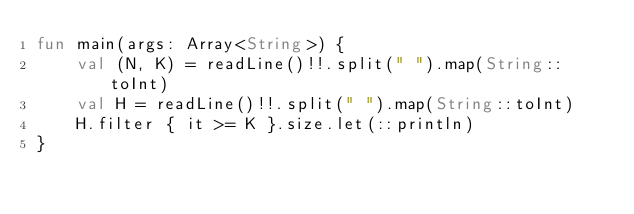Convert code to text. <code><loc_0><loc_0><loc_500><loc_500><_Kotlin_>fun main(args: Array<String>) {
    val (N, K) = readLine()!!.split(" ").map(String::toInt)
    val H = readLine()!!.split(" ").map(String::toInt)
    H.filter { it >= K }.size.let(::println)
}</code> 